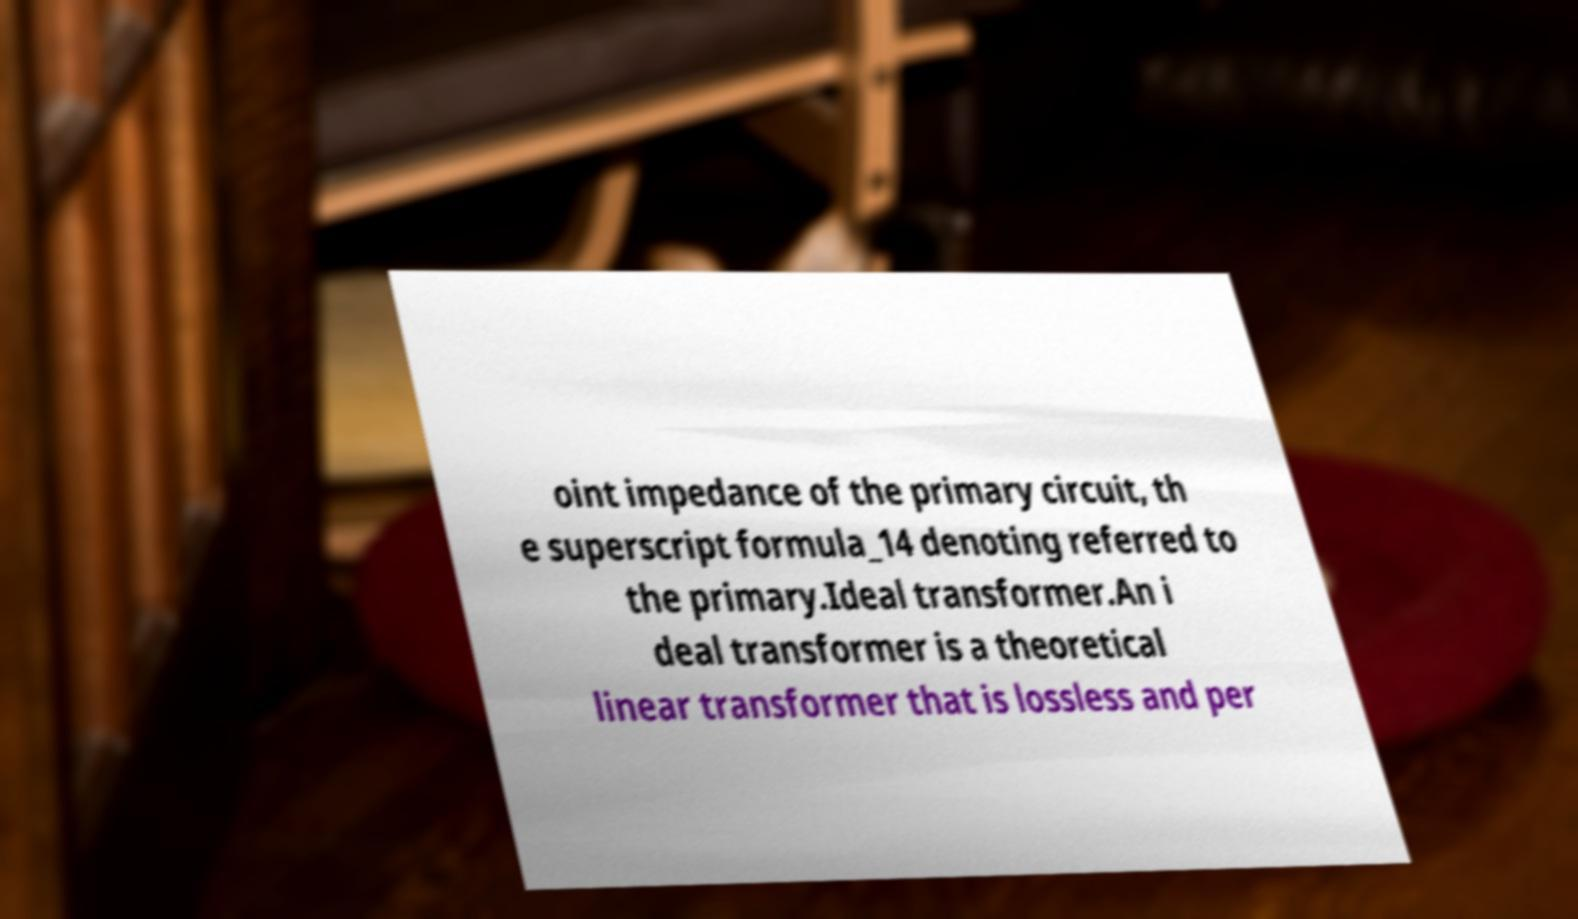What messages or text are displayed in this image? I need them in a readable, typed format. oint impedance of the primary circuit, th e superscript formula_14 denoting referred to the primary.Ideal transformer.An i deal transformer is a theoretical linear transformer that is lossless and per 